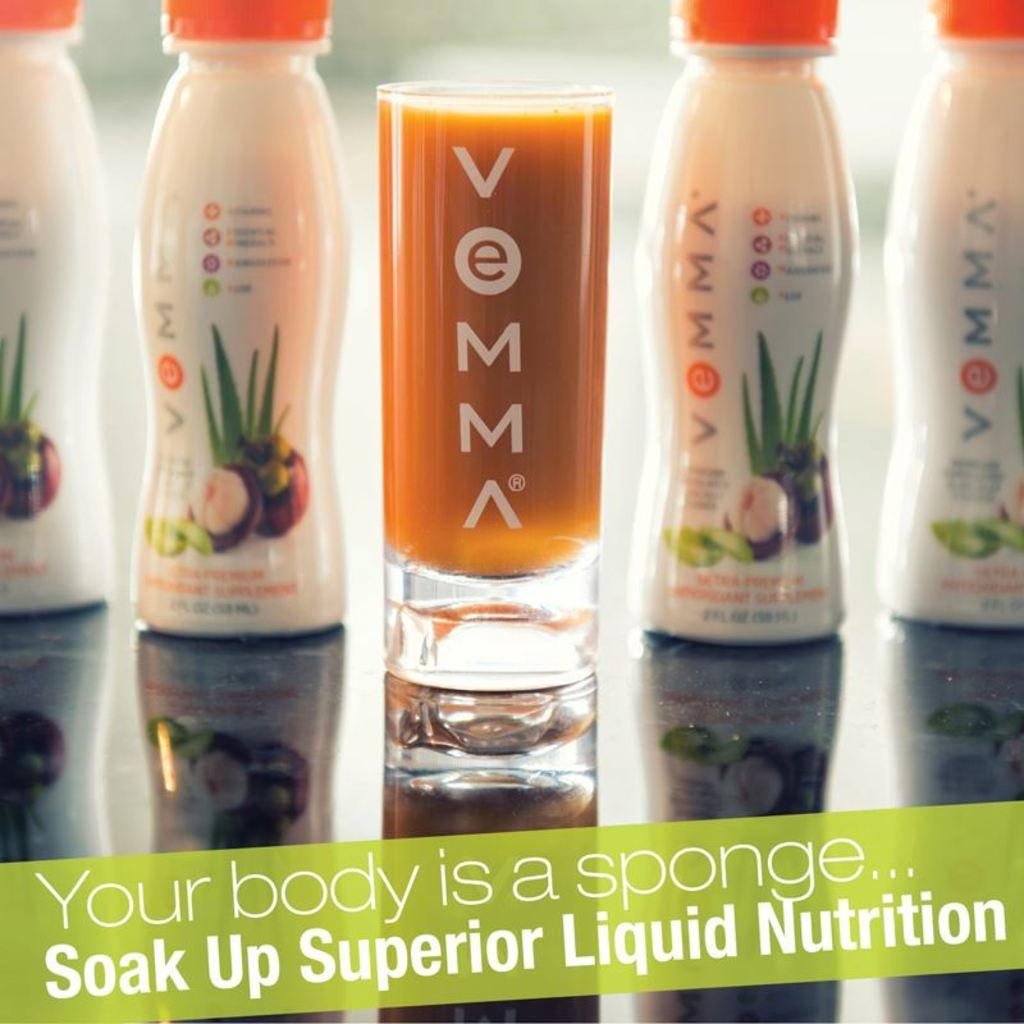Provide a one-sentence caption for the provided image. Soak up superior liquid nutrition; an ad for a smoothie. 